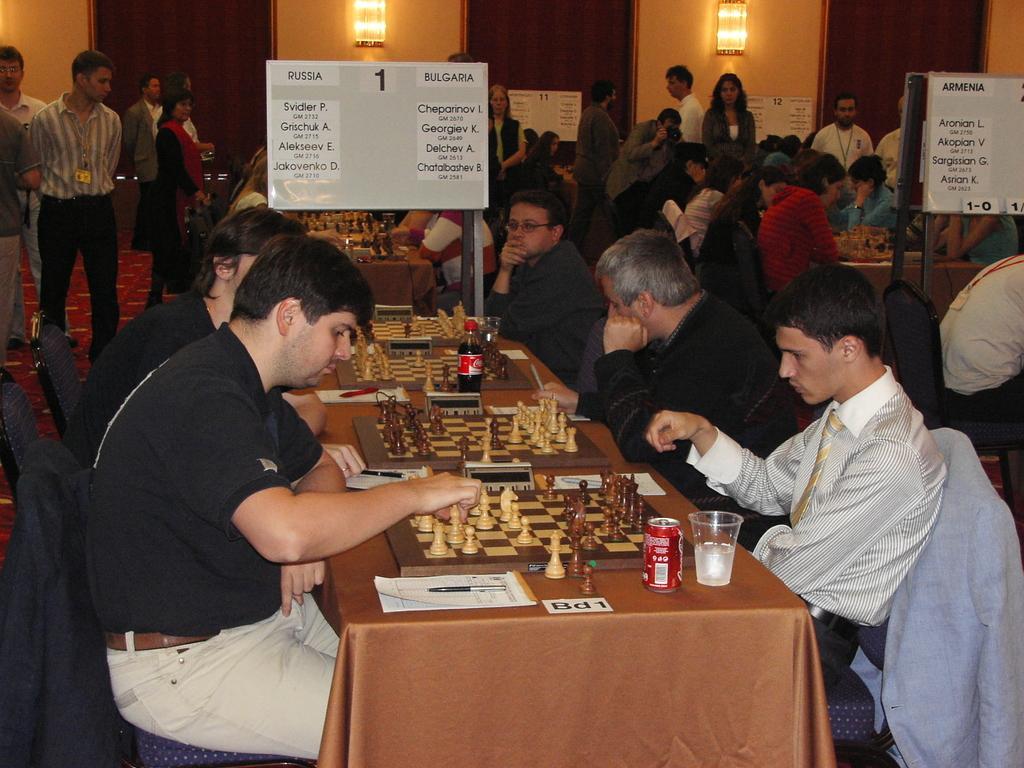How would you summarize this image in a sentence or two? Here we can see a group of people sitting on chairs with tables in front of them having chess boards and they are playing chess and there are coke cans and glasses present on the table and we can see some people standing here and there, there are name boards present in front of them and there are lights present 